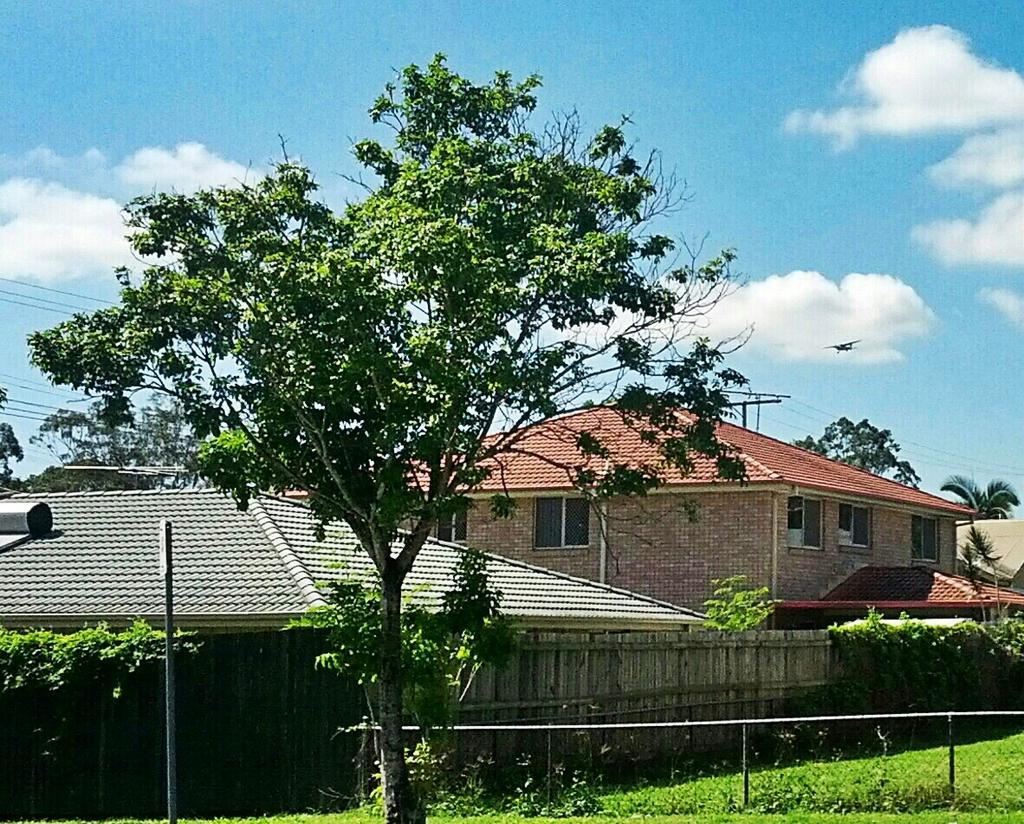What type of structures can be seen in the image? There are houses in the image. What natural elements are present in the image? There are trees and plants in the image. What man-made objects can be seen in the image? There are poles and wires in the image. What is the ground like in the image? The ground with grass is visible in the image. What type of barrier is present in the image? There is a fence in the image. What can be seen in the sky in the image? The sky with clouds is visible in the image. Can you describe the street in the image? There is no street present in the image; it features houses, trees, plants, poles, wires, grass, a fence, and a sky with clouds. How many trees are interacting with the earthquake in the image? There is no earthquake present in the image, and therefore no interaction with trees can be observed. 